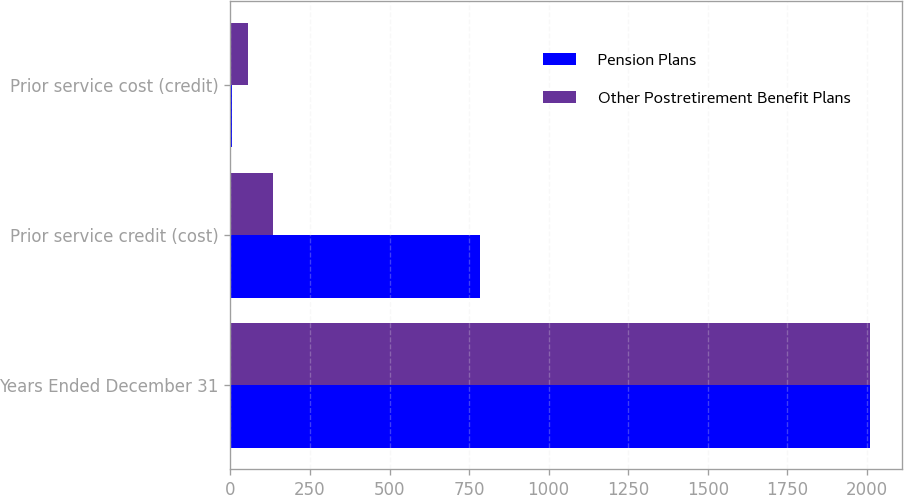<chart> <loc_0><loc_0><loc_500><loc_500><stacked_bar_chart><ecel><fcel>Years Ended December 31<fcel>Prior service credit (cost)<fcel>Prior service cost (credit)<nl><fcel>Pension Plans<fcel>2011<fcel>783<fcel>5<nl><fcel>Other Postretirement Benefit Plans<fcel>2011<fcel>133<fcel>55<nl></chart> 